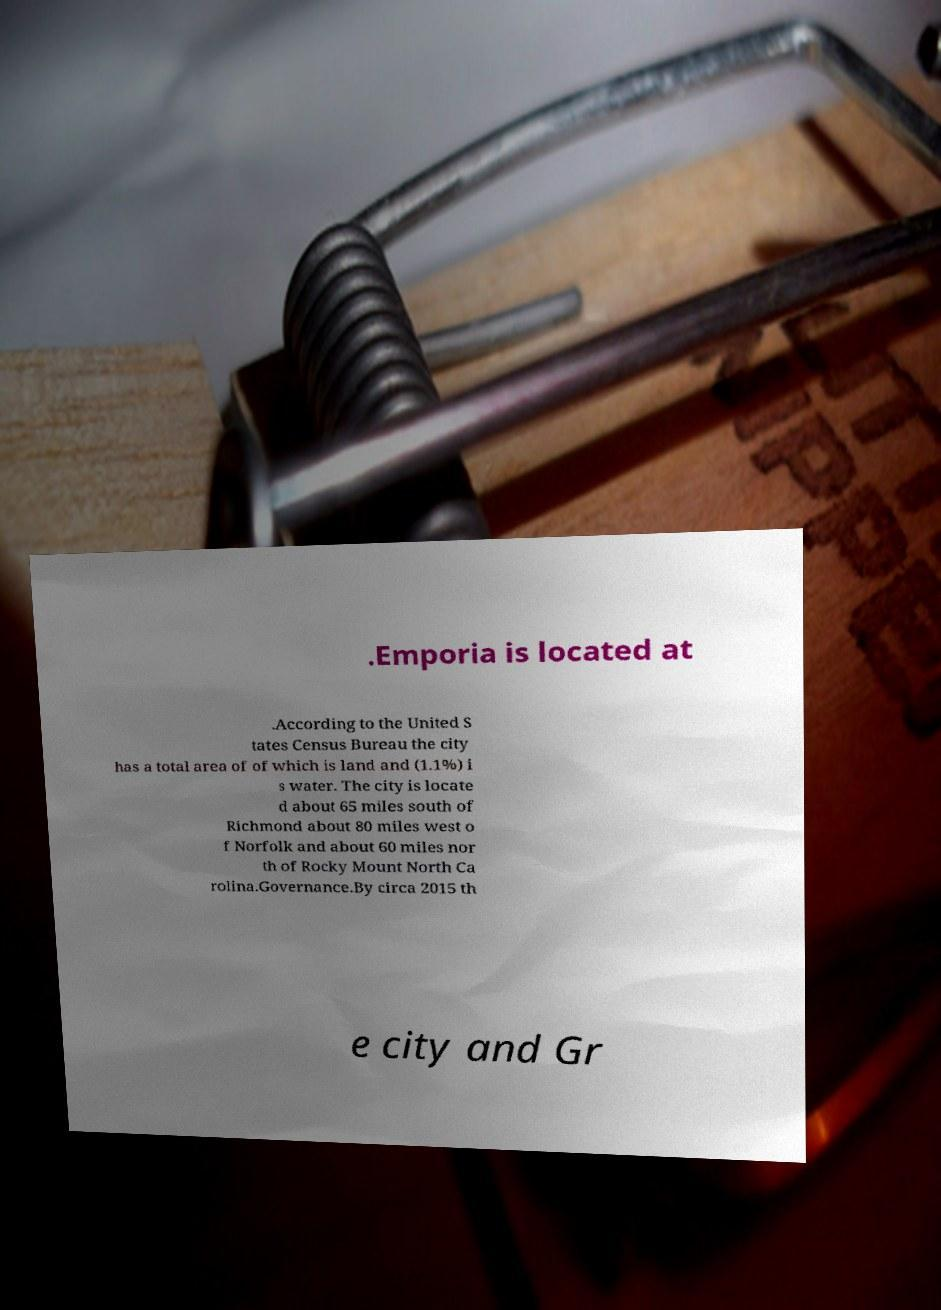There's text embedded in this image that I need extracted. Can you transcribe it verbatim? .Emporia is located at .According to the United S tates Census Bureau the city has a total area of of which is land and (1.1%) i s water. The city is locate d about 65 miles south of Richmond about 80 miles west o f Norfolk and about 60 miles nor th of Rocky Mount North Ca rolina.Governance.By circa 2015 th e city and Gr 